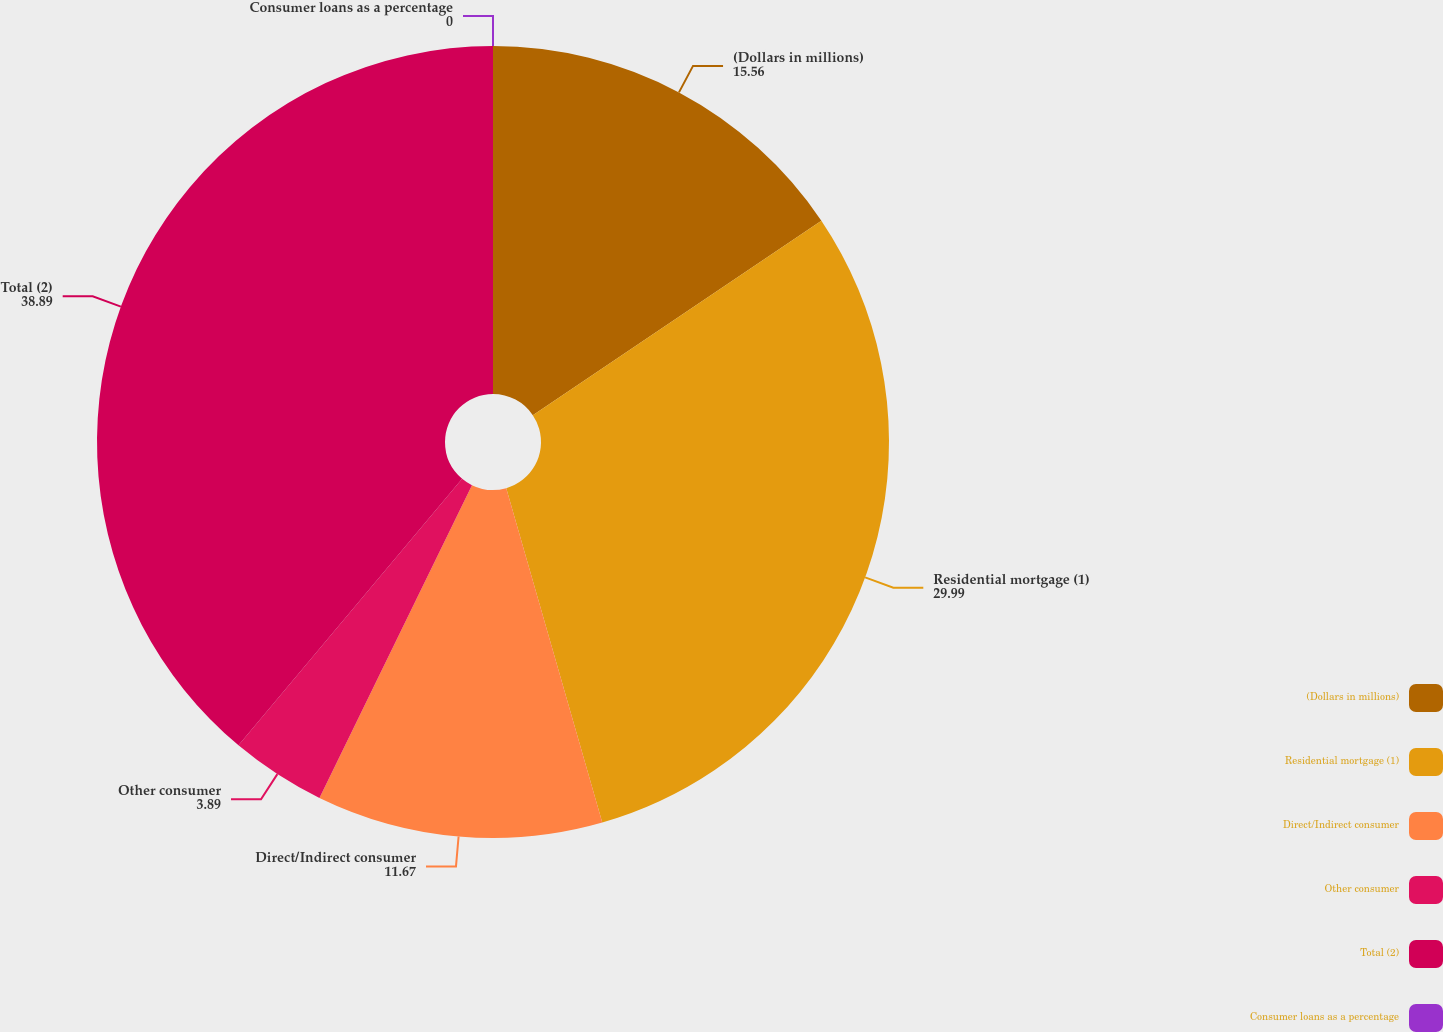Convert chart to OTSL. <chart><loc_0><loc_0><loc_500><loc_500><pie_chart><fcel>(Dollars in millions)<fcel>Residential mortgage (1)<fcel>Direct/Indirect consumer<fcel>Other consumer<fcel>Total (2)<fcel>Consumer loans as a percentage<nl><fcel>15.56%<fcel>29.99%<fcel>11.67%<fcel>3.89%<fcel>38.89%<fcel>0.0%<nl></chart> 